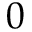<formula> <loc_0><loc_0><loc_500><loc_500>0</formula> 